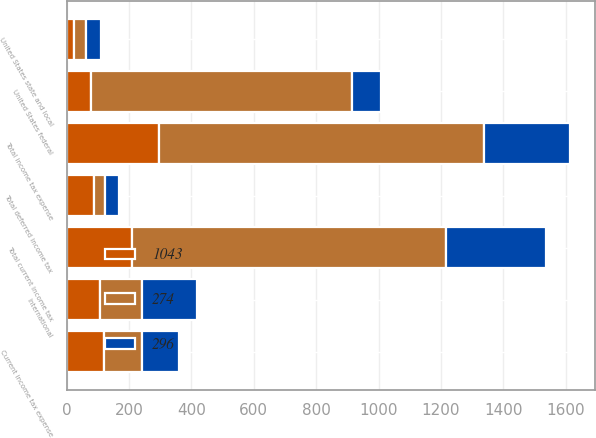<chart> <loc_0><loc_0><loc_500><loc_500><stacked_bar_chart><ecel><fcel>Current income tax expense<fcel>United States federal<fcel>United States state and local<fcel>International<fcel>Total current income tax<fcel>Total deferred income tax<fcel>Total income tax expense<nl><fcel>274<fcel>120.5<fcel>836<fcel>38<fcel>133<fcel>1007<fcel>36<fcel>1043<nl><fcel>296<fcel>120.5<fcel>94<fcel>50<fcel>176<fcel>320<fcel>46<fcel>274<nl><fcel>1043<fcel>120.5<fcel>78<fcel>23<fcel>108<fcel>209<fcel>87<fcel>296<nl></chart> 